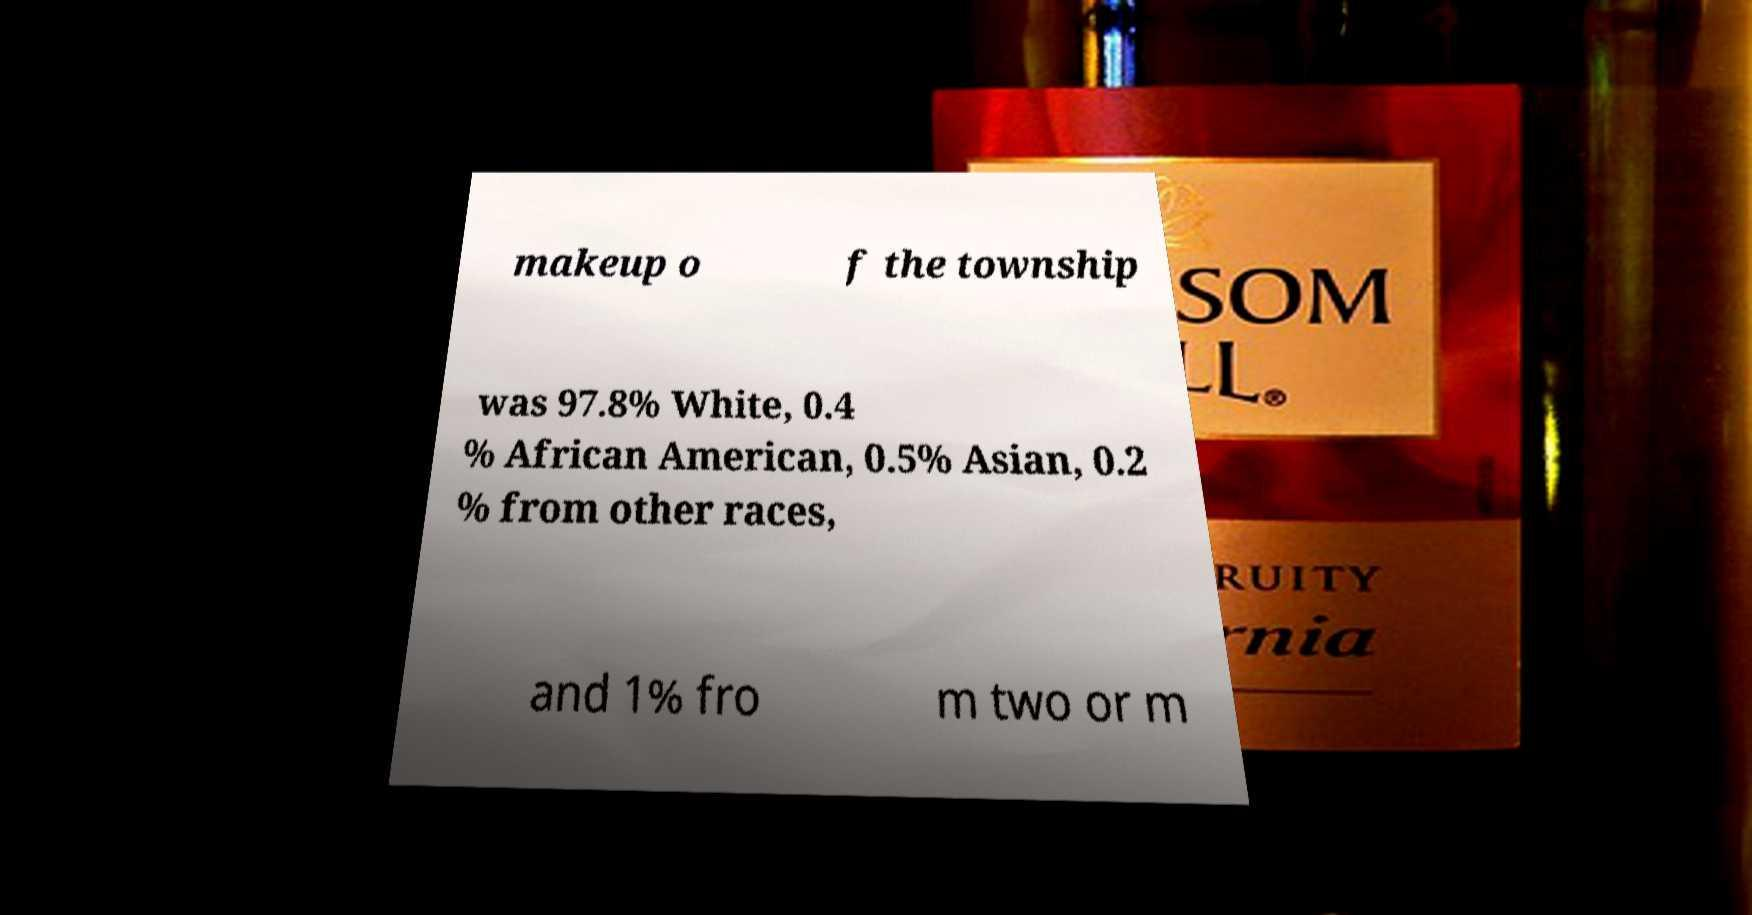Could you assist in decoding the text presented in this image and type it out clearly? makeup o f the township was 97.8% White, 0.4 % African American, 0.5% Asian, 0.2 % from other races, and 1% fro m two or m 